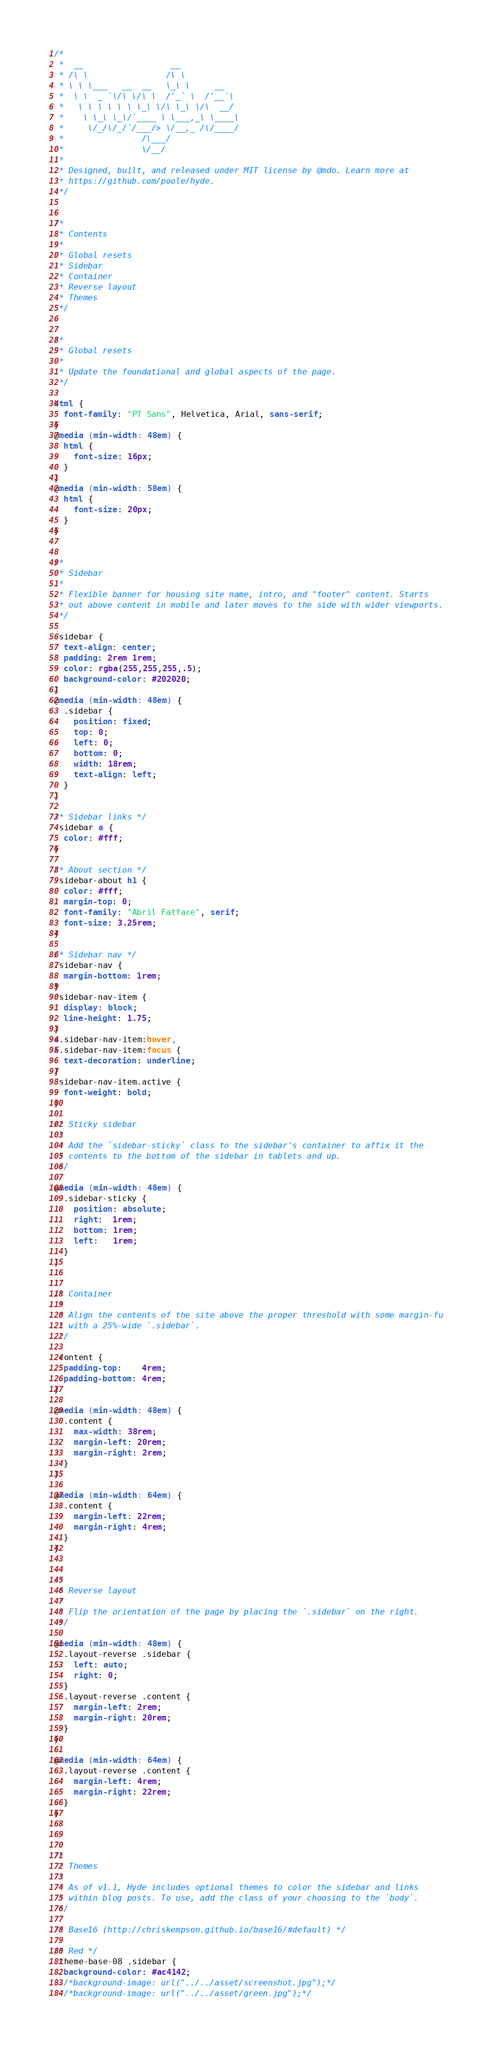Convert code to text. <code><loc_0><loc_0><loc_500><loc_500><_CSS_>/*
 *  __                  __
 * /\ \                /\ \
 * \ \ \___   __  __   \_\ \     __
 *  \ \  _ `\/\ \/\ \  /'_` \  /'__`\
 *   \ \ \ \ \ \ \_\ \/\ \_\ \/\  __/
 *    \ \_\ \_\/`____ \ \___,_\ \____\
 *     \/_/\/_/`/___/> \/__,_ /\/____/
 *                /\___/
 *                \/__/
 *
 * Designed, built, and released under MIT license by @mdo. Learn more at
 * https://github.com/poole/hyde.
 */


/*
 * Contents
 *
 * Global resets
 * Sidebar
 * Container
 * Reverse layout
 * Themes
 */


/*
 * Global resets
 *
 * Update the foundational and global aspects of the page.
 */

html {
  font-family: "PT Sans", Helvetica, Arial, sans-serif;
}
@media (min-width: 48em) {
  html {
    font-size: 16px;
  }
}
@media (min-width: 58em) {
  html {
    font-size: 20px;
  }
}


/*
 * Sidebar
 *
 * Flexible banner for housing site name, intro, and "footer" content. Starts
 * out above content in mobile and later moves to the side with wider viewports.
 */

.sidebar {
  text-align: center;
  padding: 2rem 1rem;
  color: rgba(255,255,255,.5);
  background-color: #202020;
}
@media (min-width: 48em) {
  .sidebar {
    position: fixed;
    top: 0;
    left: 0;
    bottom: 0;
    width: 18rem;
    text-align: left;
  }
}

/* Sidebar links */
.sidebar a {
  color: #fff;
}

/* About section */
.sidebar-about h1 {
  color: #fff;
  margin-top: 0;
  font-family: "Abril Fatface", serif;
  font-size: 3.25rem;
}

/* Sidebar nav */
.sidebar-nav {
  margin-bottom: 1rem;
}
.sidebar-nav-item {
  display: block;
  line-height: 1.75;
}
a.sidebar-nav-item:hover,
a.sidebar-nav-item:focus {
  text-decoration: underline;
}
.sidebar-nav-item.active {
  font-weight: bold;
}

/* Sticky sidebar
 *
 * Add the `sidebar-sticky` class to the sidebar's container to affix it the
 * contents to the bottom of the sidebar in tablets and up.
 */

@media (min-width: 48em) {
  .sidebar-sticky {
    position: absolute;
    right:  1rem;
    bottom: 1rem;
    left:   1rem;
  }
}


/* Container
 *
 * Align the contents of the site above the proper threshold with some margin-fu
 * with a 25%-wide `.sidebar`.
 */

.content {
  padding-top:    4rem;
  padding-bottom: 4rem;
}

@media (min-width: 48em) {
  .content {
    max-width: 38rem;
    margin-left: 20rem;
    margin-right: 2rem;
  }
}

@media (min-width: 64em) {
  .content {
    margin-left: 22rem;
    margin-right: 4rem;
  }
}


/*
 * Reverse layout
 *
 * Flip the orientation of the page by placing the `.sidebar` on the right.
 */

@media (min-width: 48em) {
  .layout-reverse .sidebar {
    left: auto;
    right: 0;
  }
  .layout-reverse .content {
    margin-left: 2rem;
    margin-right: 20rem;
  }
}

@media (min-width: 64em) {
  .layout-reverse .content {
    margin-left: 4rem;
    margin-right: 22rem;
  }
}



/*
 * Themes
 *
 * As of v1.1, Hyde includes optional themes to color the sidebar and links
 * within blog posts. To use, add the class of your choosing to the `body`.
 */

/* Base16 (http://chriskempson.github.io/base16/#default) */

/* Red */
.theme-base-08 .sidebar {
  background-color: #ac4142;
  /*background-image: url("../../asset/screenshot.jpg");*/
  /*background-image: url("../../asset/green.jpg");*/</code> 